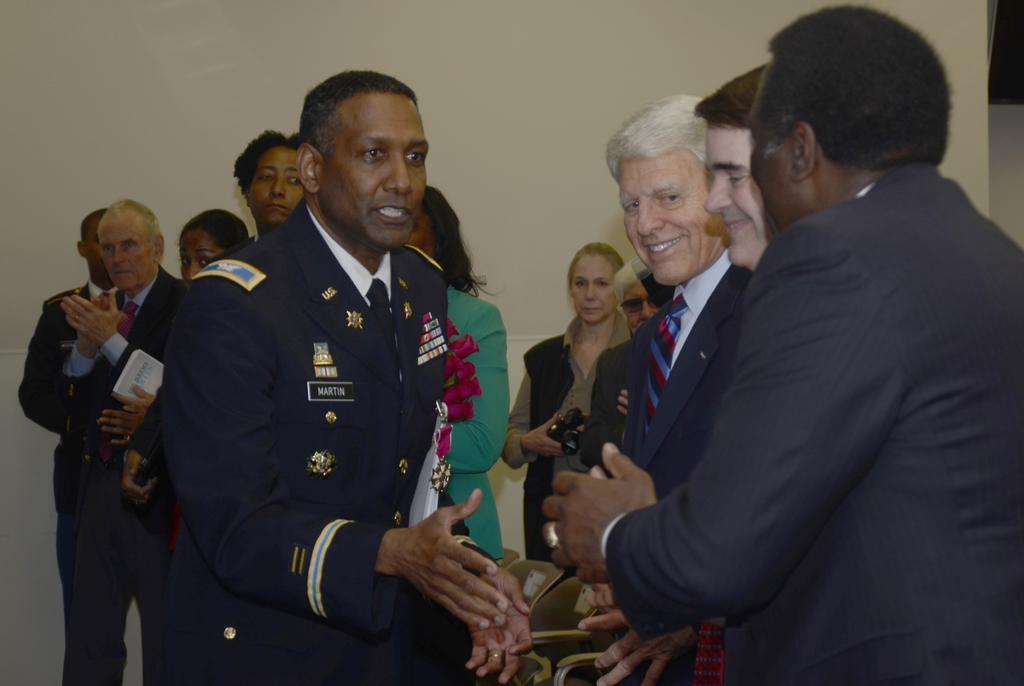In one or two sentences, can you explain what this image depicts? In this image, we can see a group of people. Few people are smiling. In the middle of the image, we can see a woman holding a camera. At the bottom of the image, we can see chairs. On the left side of the image, we can see a man clapping his hands and another person holding a book. We can see the wall in the background of the image. 